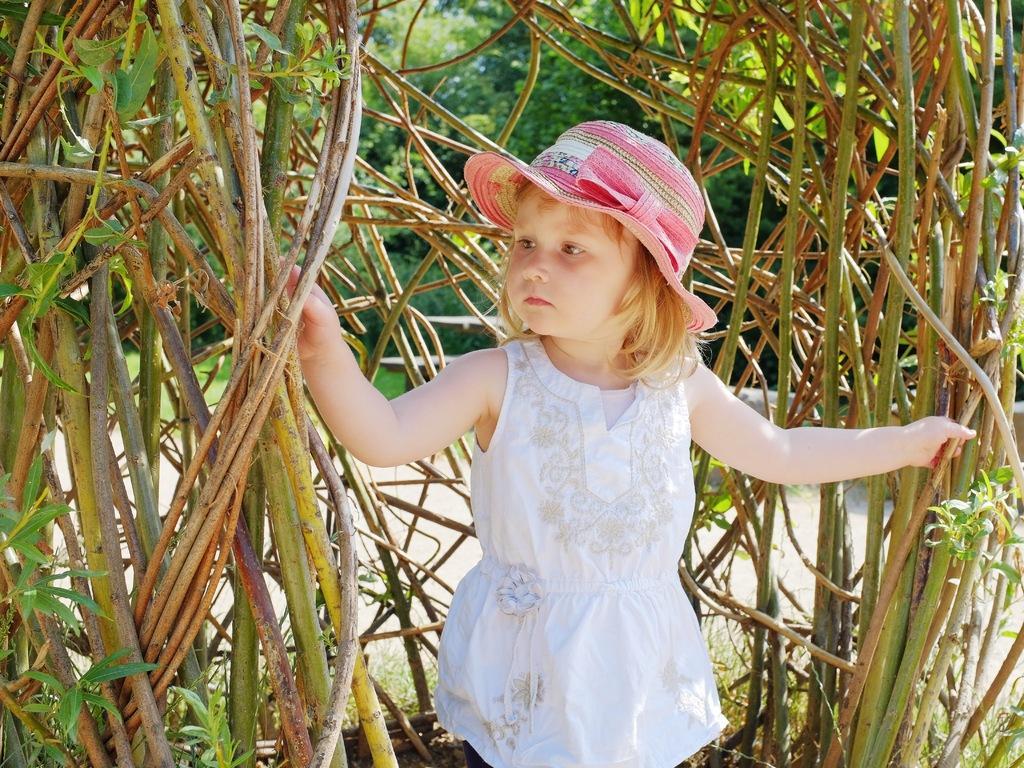Can you describe this image briefly? In this image in the center there is a girl standing holding plants. In the background there are trees. 